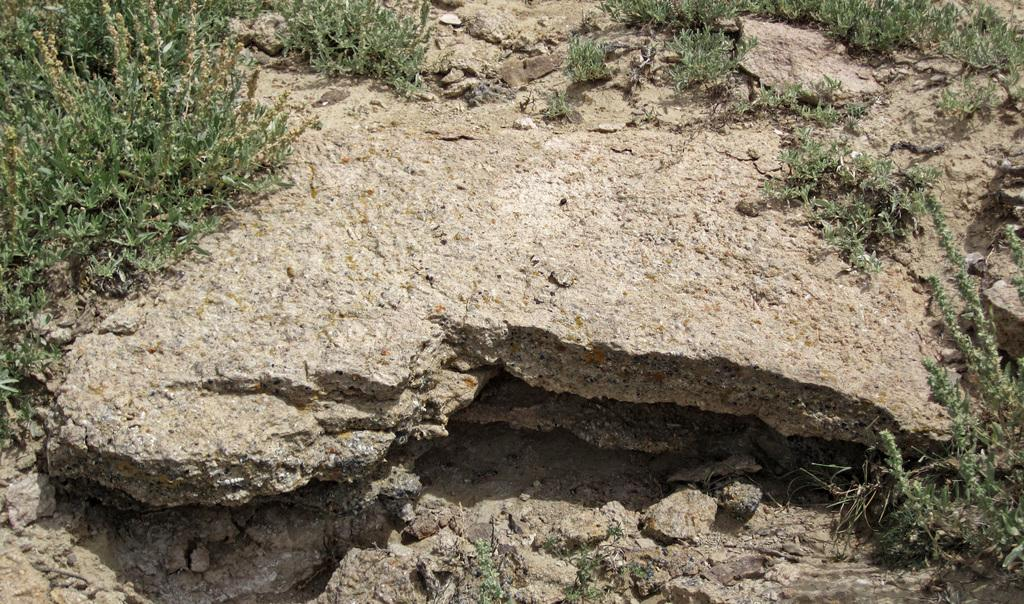What type of vegetation is present in the image? There is grass in the image. What other objects can be seen in the image? There are rocks and stones in the image. Can you determine the time of day the image was taken? The image was likely taken during the day, as there is sufficient light to see the details. How many cows are grazing in the grass in the image? There are no cows present in the image; it only features grass, rocks, and stones. 